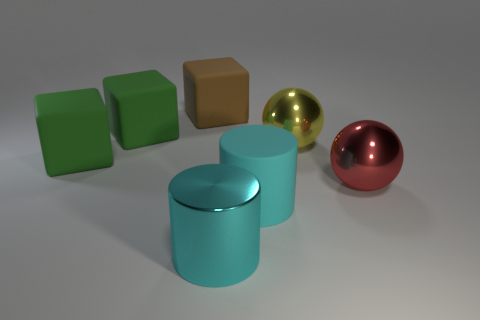Subtract all cyan cylinders. How many were subtracted if there are1cyan cylinders left? 1 Subtract all brown cubes. How many cubes are left? 2 Subtract all cylinders. How many objects are left? 5 Subtract 1 blocks. How many blocks are left? 2 Add 2 small cyan shiny things. How many objects exist? 9 Subtract all yellow balls. How many balls are left? 1 Subtract 1 yellow spheres. How many objects are left? 6 Subtract all cyan spheres. Subtract all red cubes. How many spheres are left? 2 Subtract all blue balls. How many brown cubes are left? 1 Subtract all cyan rubber cylinders. Subtract all cyan objects. How many objects are left? 4 